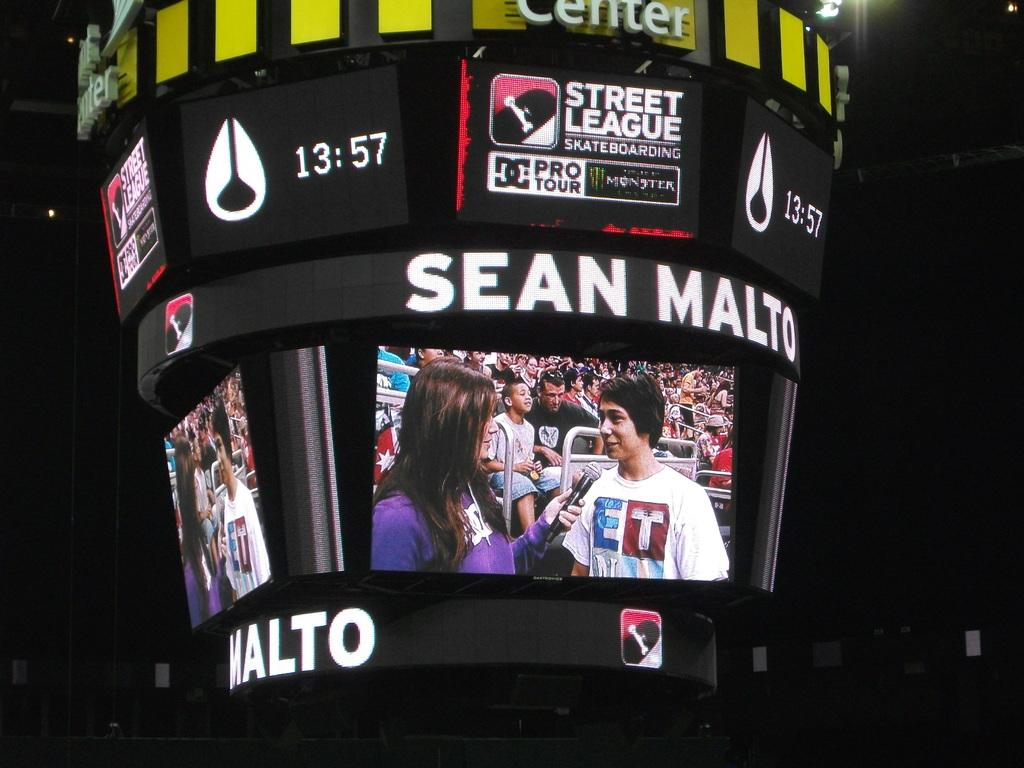<image>
Provide a brief description of the given image. A large score board monitor that has Sean Malto on it. 